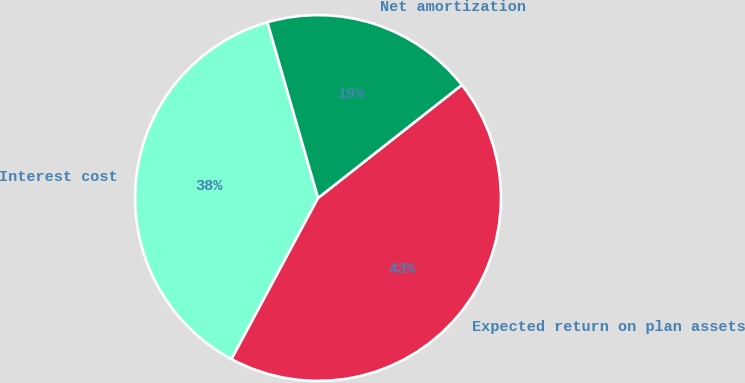Convert chart to OTSL. <chart><loc_0><loc_0><loc_500><loc_500><pie_chart><fcel>Interest cost<fcel>Expected return on plan assets<fcel>Net amortization<nl><fcel>37.69%<fcel>43.45%<fcel>18.86%<nl></chart> 